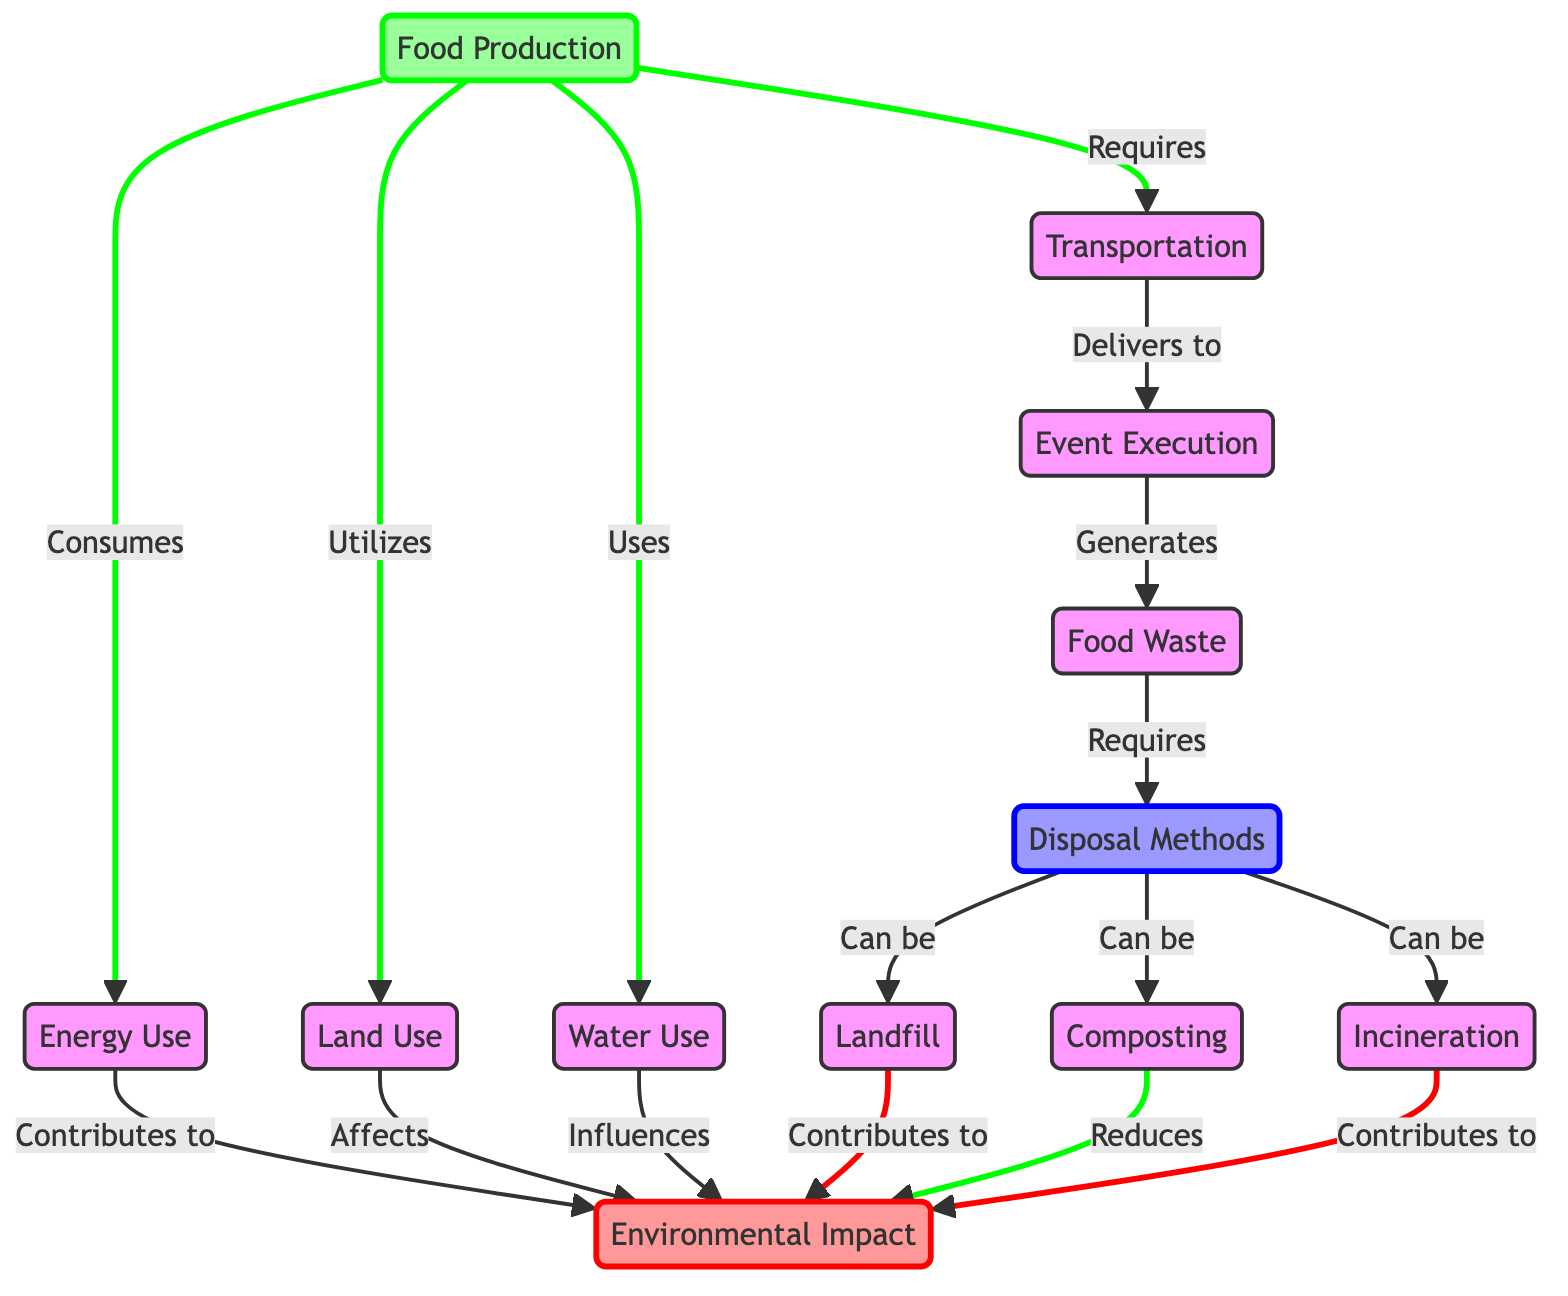What is the first step in the diagram? The first node listed in the directional flow is "Food Production," indicating it's the initiation point of the process shown in the diagram.
Answer: Food Production How many disposal methods are shown in the diagram? The diagram illustrates three disposal methods: landfill, composting, and incineration. Counting these, the total is three.
Answer: 3 What impact does composting have on the environment? The diagram specifies that composting “Reduces” the environmental impact, indicating a positive outcome when food waste is composted.
Answer: Reduces Which factor contributes to the environmental impact as per the event execution phase? The event execution generates food waste, which is indicated as an arrow leading to the food waste node that requires disposal methods, ultimately affecting environmental impact.
Answer: Food Waste How does transportation relate to food production? The diagram shows that food production requires transportation, linking these two aspects and highlighting the dependency of food production on the transportation of produced goods.
Answer: Requires What three resources are consumed in the food production process? The diagram indicates that food production consumes energy, land, and water as key resources, linking these directly to food production in the first phase.
Answer: Energy, Land, Water Which disposal method contributes to the environmental impact? Both the landfill and incineration disposal routes are shown as contributing to the environmental impact, with established links directing from these methods to the environmental impact node.
Answer: Landfill, Incineration Which part of the diagram can be classified as a process that impacts the environment negatively? The land use aspect is illustrated with a direct link contributing to environmental impact, suggesting that its utilization affects the environment negatively.
Answer: Land Use What does the node "Event Execution" generate? The diagram clearly states that the event execution generates food waste, represented by an arrow leading to the food waste node.
Answer: Food Waste 